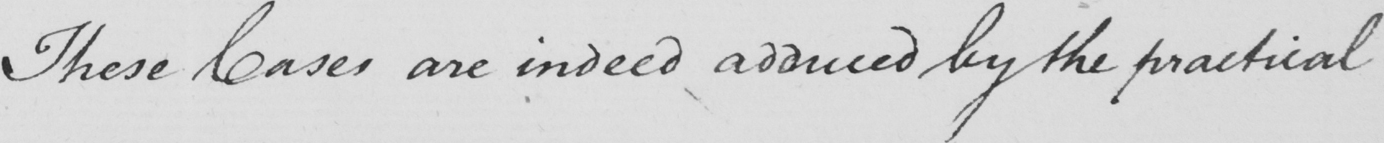Please transcribe the handwritten text in this image. These Cases are indeed adduced by the practical 